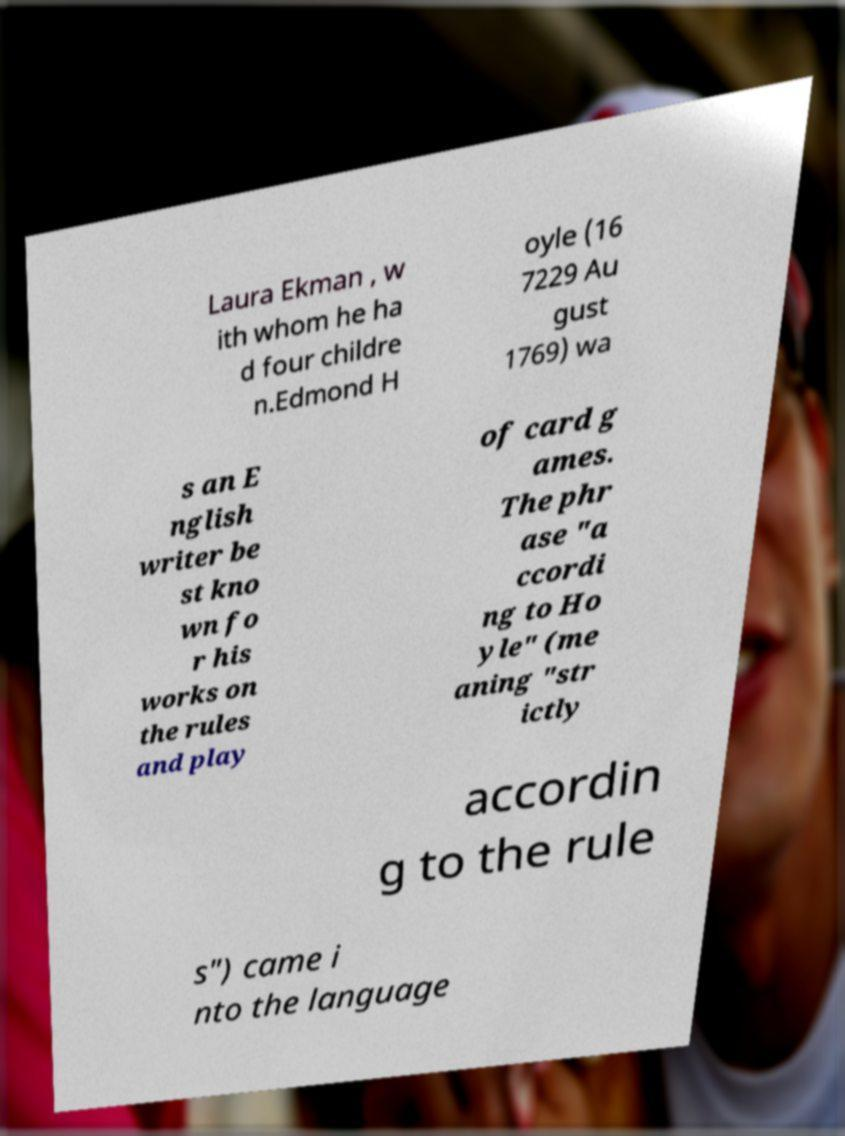Can you accurately transcribe the text from the provided image for me? Laura Ekman , w ith whom he ha d four childre n.Edmond H oyle (16 7229 Au gust 1769) wa s an E nglish writer be st kno wn fo r his works on the rules and play of card g ames. The phr ase "a ccordi ng to Ho yle" (me aning "str ictly accordin g to the rule s") came i nto the language 